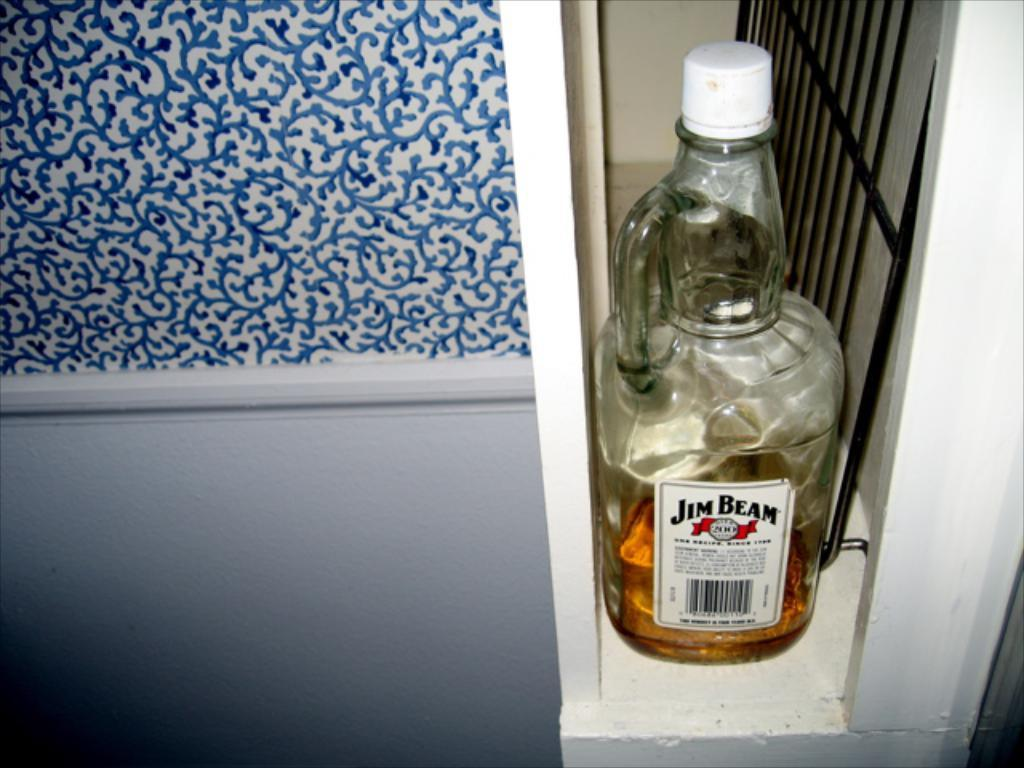Provide a one-sentence caption for the provided image. A bottle of Jim Bean that is almost finished in a cabinet. 